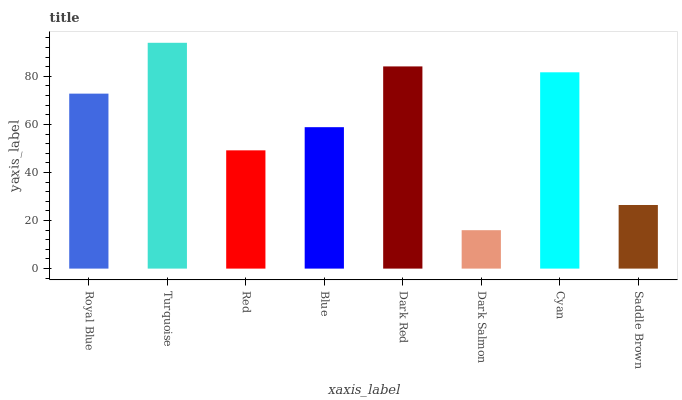Is Dark Salmon the minimum?
Answer yes or no. Yes. Is Turquoise the maximum?
Answer yes or no. Yes. Is Red the minimum?
Answer yes or no. No. Is Red the maximum?
Answer yes or no. No. Is Turquoise greater than Red?
Answer yes or no. Yes. Is Red less than Turquoise?
Answer yes or no. Yes. Is Red greater than Turquoise?
Answer yes or no. No. Is Turquoise less than Red?
Answer yes or no. No. Is Royal Blue the high median?
Answer yes or no. Yes. Is Blue the low median?
Answer yes or no. Yes. Is Saddle Brown the high median?
Answer yes or no. No. Is Turquoise the low median?
Answer yes or no. No. 